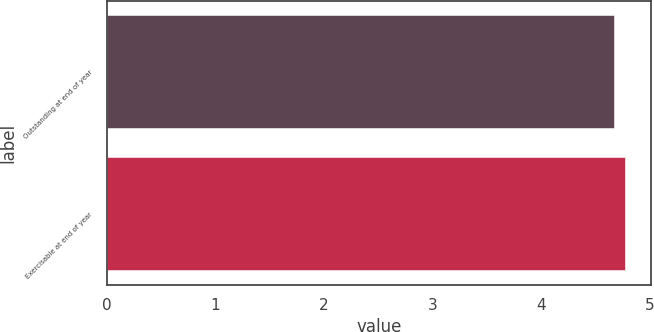Convert chart to OTSL. <chart><loc_0><loc_0><loc_500><loc_500><bar_chart><fcel>Outstanding at end of year<fcel>Exercisable at end of year<nl><fcel>4.67<fcel>4.77<nl></chart> 